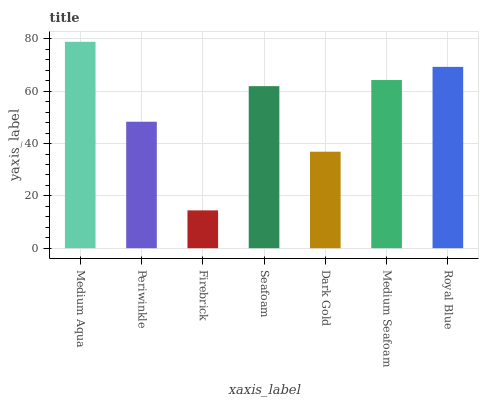Is Firebrick the minimum?
Answer yes or no. Yes. Is Medium Aqua the maximum?
Answer yes or no. Yes. Is Periwinkle the minimum?
Answer yes or no. No. Is Periwinkle the maximum?
Answer yes or no. No. Is Medium Aqua greater than Periwinkle?
Answer yes or no. Yes. Is Periwinkle less than Medium Aqua?
Answer yes or no. Yes. Is Periwinkle greater than Medium Aqua?
Answer yes or no. No. Is Medium Aqua less than Periwinkle?
Answer yes or no. No. Is Seafoam the high median?
Answer yes or no. Yes. Is Seafoam the low median?
Answer yes or no. Yes. Is Medium Aqua the high median?
Answer yes or no. No. Is Periwinkle the low median?
Answer yes or no. No. 